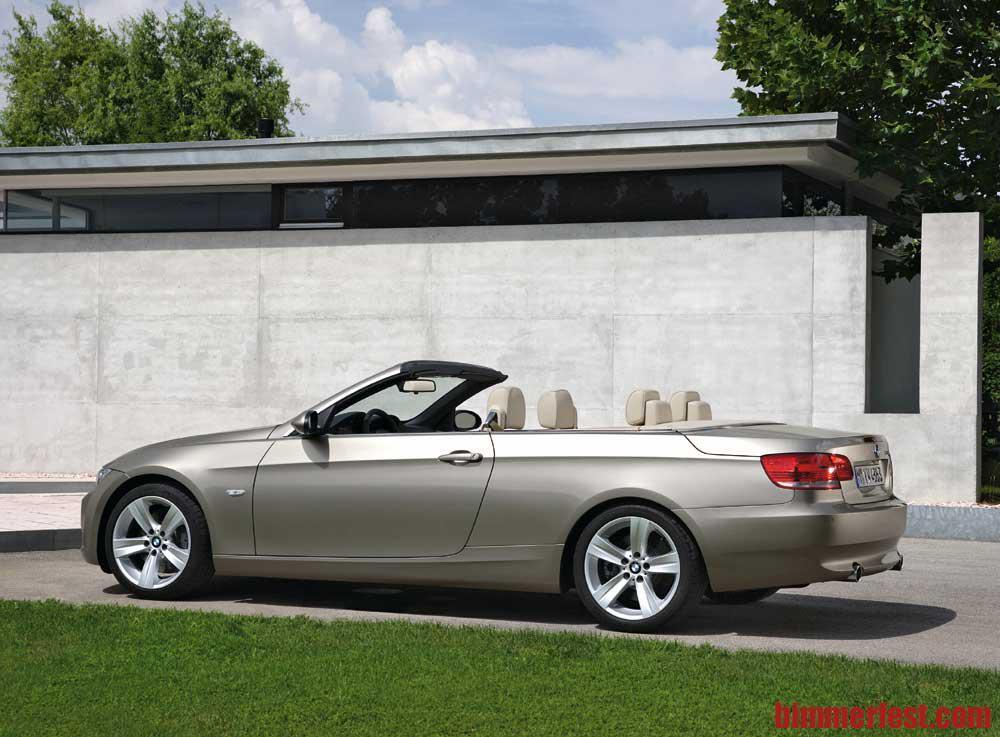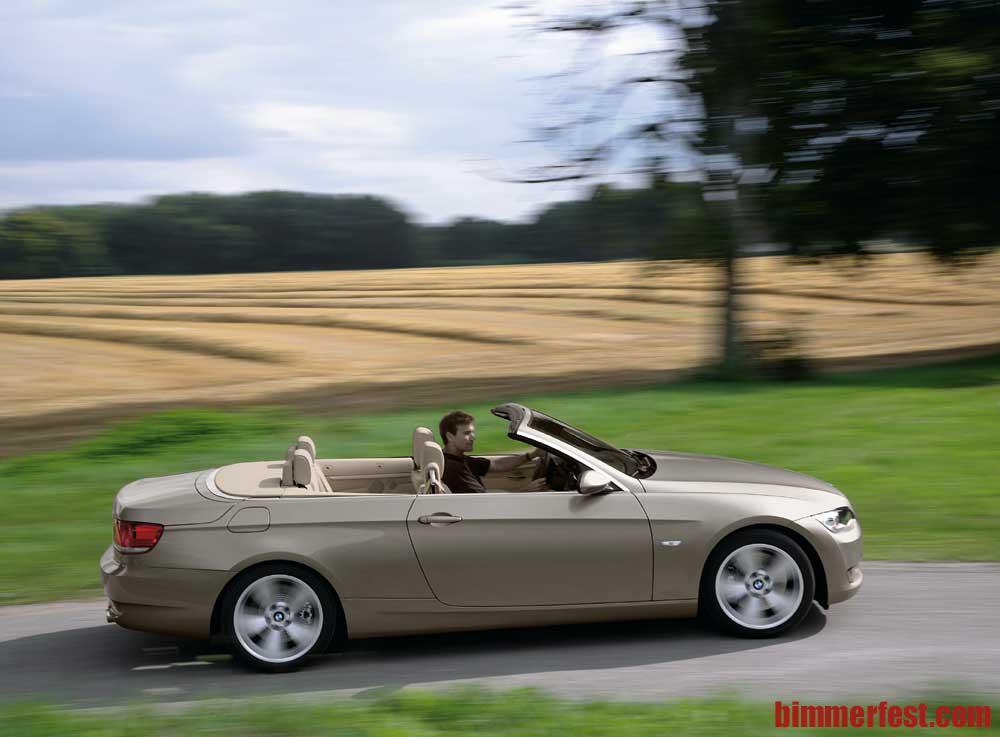The first image is the image on the left, the second image is the image on the right. Given the left and right images, does the statement "In one of the images, the top of the convertible car is in the middle of coming up or down" hold true? Answer yes or no. No. The first image is the image on the left, the second image is the image on the right. For the images shown, is this caption "dark colored convertibles are on oposite sides" true? Answer yes or no. No. 